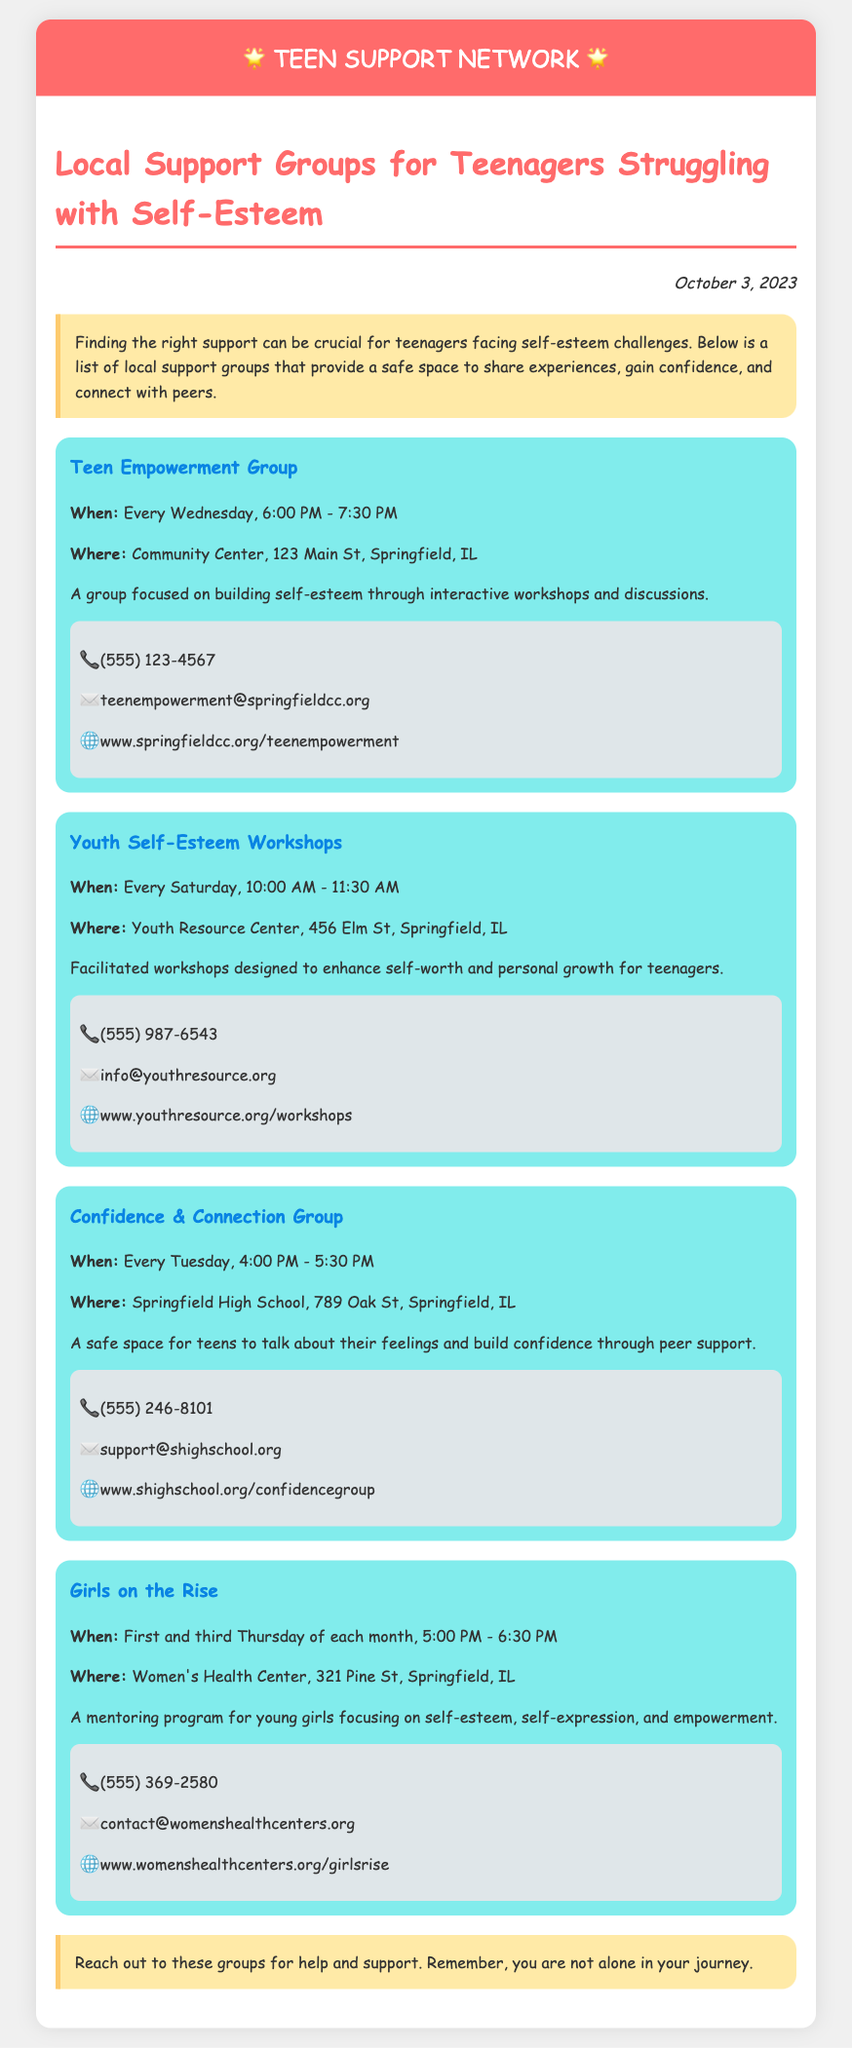What is the name of the first support group? The document lists "Teen Empowerment Group" as the first support group in the list.
Answer: Teen Empowerment Group When does the Confidence & Connection Group meet? The meeting time for the Confidence & Connection Group is provided in the document as every Tuesday from 4:00 PM to 5:30 PM.
Answer: Every Tuesday, 4:00 PM - 5:30 PM Where is the Youth Resource Center located? The document specifies the address of the Youth Resource Center as 456 Elm St, Springfield, IL.
Answer: 456 Elm St, Springfield, IL What is the contact email for Girls on the Rise? The document provides the contact email for Girls on the Rise as contact@womenshealthcenters.org.
Answer: contact@womenshealthcenters.org How often does the Girls on the Rise group meet? The document states that Girls on the Rise meets on the first and third Thursday of each month, which requires inferring from the schedule.
Answer: First and third Thursday of each month Which group meets at Springfield High School? The document identifies the Confidence & Connection Group as the one that meets at Springfield High School.
Answer: Confidence & Connection Group What is the main focus of the Youth Self-Esteem Workshops? The document states that the Youth Self-Esteem Workshops aim to enhance self-worth and personal growth for teenagers, indicating the group’s purpose.
Answer: Enhance self-worth and personal growth What type of document is this? The structure and content indicate that it is a memo listing local support groups, designed to provide information and support for a specific audience.
Answer: Memo 